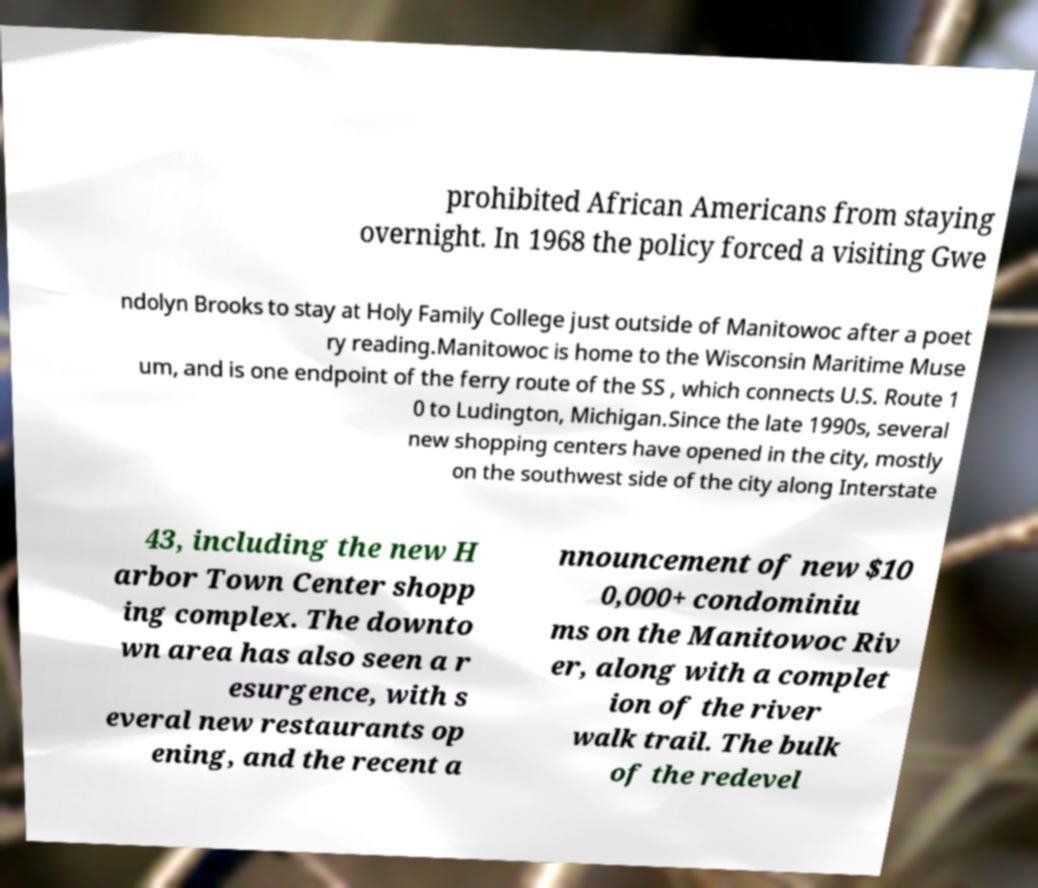What messages or text are displayed in this image? I need them in a readable, typed format. prohibited African Americans from staying overnight. In 1968 the policy forced a visiting Gwe ndolyn Brooks to stay at Holy Family College just outside of Manitowoc after a poet ry reading.Manitowoc is home to the Wisconsin Maritime Muse um, and is one endpoint of the ferry route of the SS , which connects U.S. Route 1 0 to Ludington, Michigan.Since the late 1990s, several new shopping centers have opened in the city, mostly on the southwest side of the city along Interstate 43, including the new H arbor Town Center shopp ing complex. The downto wn area has also seen a r esurgence, with s everal new restaurants op ening, and the recent a nnouncement of new $10 0,000+ condominiu ms on the Manitowoc Riv er, along with a complet ion of the river walk trail. The bulk of the redevel 